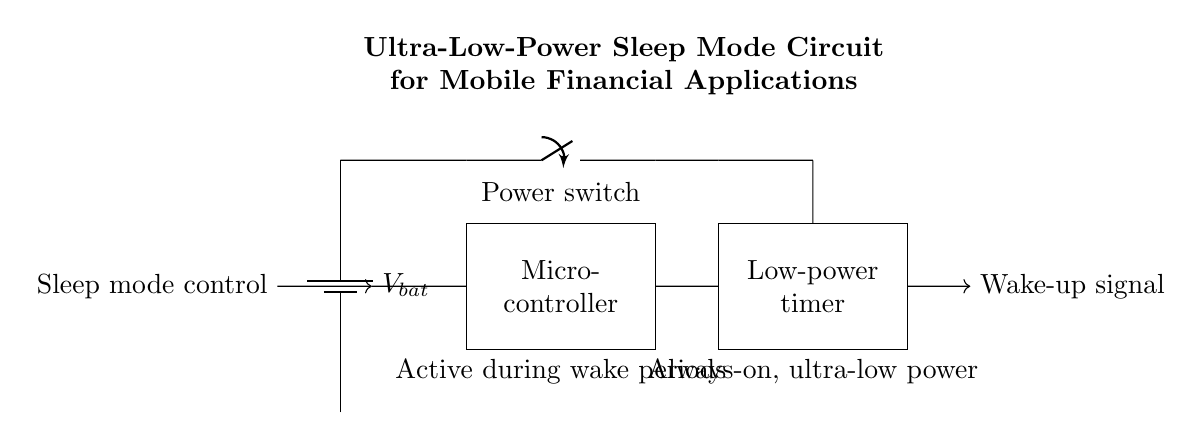What is the main power supply type in this circuit? The main power supply type is a battery, indicated by the battery symbol at the top of the diagram.
Answer: Battery What component controls the sleep mode? The sleep mode is controlled by the microcontroller, as depicted in the rectangle that represents it; it receives the sleep mode control signal to manage power consumption.
Answer: Microcontroller How many main components are actively used during wake periods? The active components during wake periods are the microcontroller and the low-power timer, identified in the diagram; the microcontroller is crucial for processing, and the low-power timer manages timing while consuming minimal power.
Answer: Two What is the function of the low-power timer in this circuit? The low-power timer operates continuously, allowing the circuit to wake the microcontroller from sleep mode, indicated by the “Always-on, ultra-low power” label under the timer.
Answer: Wake-up timing What happens when the power switch is closed? When the power switch is closed, it connects the battery to the microcontroller and the low-power timer, allowing them to receive voltage and function, as shown by the connection lines in the diagram.
Answer: Power supply activates What is the significance of the wake-up signal? The wake-up signal is essential for alerting the microcontroller when it should exit sleep mode and become active, marked by the arrow pointing from the low-power timer to indicate the direction of the signal.
Answer: Exits sleep mode 